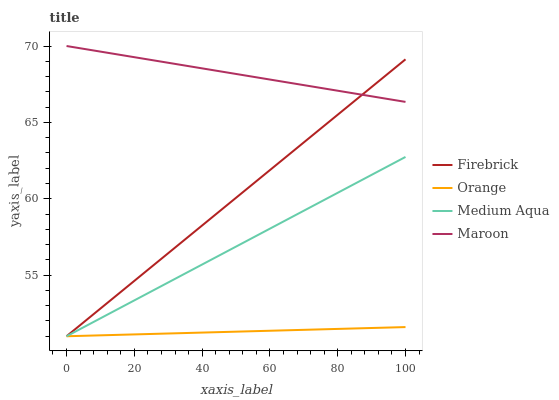Does Orange have the minimum area under the curve?
Answer yes or no. Yes. Does Maroon have the maximum area under the curve?
Answer yes or no. Yes. Does Firebrick have the minimum area under the curve?
Answer yes or no. No. Does Firebrick have the maximum area under the curve?
Answer yes or no. No. Is Firebrick the smoothest?
Answer yes or no. Yes. Is Maroon the roughest?
Answer yes or no. Yes. Is Medium Aqua the smoothest?
Answer yes or no. No. Is Medium Aqua the roughest?
Answer yes or no. No. Does Orange have the lowest value?
Answer yes or no. Yes. Does Maroon have the lowest value?
Answer yes or no. No. Does Maroon have the highest value?
Answer yes or no. Yes. Does Firebrick have the highest value?
Answer yes or no. No. Is Orange less than Maroon?
Answer yes or no. Yes. Is Maroon greater than Medium Aqua?
Answer yes or no. Yes. Does Orange intersect Firebrick?
Answer yes or no. Yes. Is Orange less than Firebrick?
Answer yes or no. No. Is Orange greater than Firebrick?
Answer yes or no. No. Does Orange intersect Maroon?
Answer yes or no. No. 